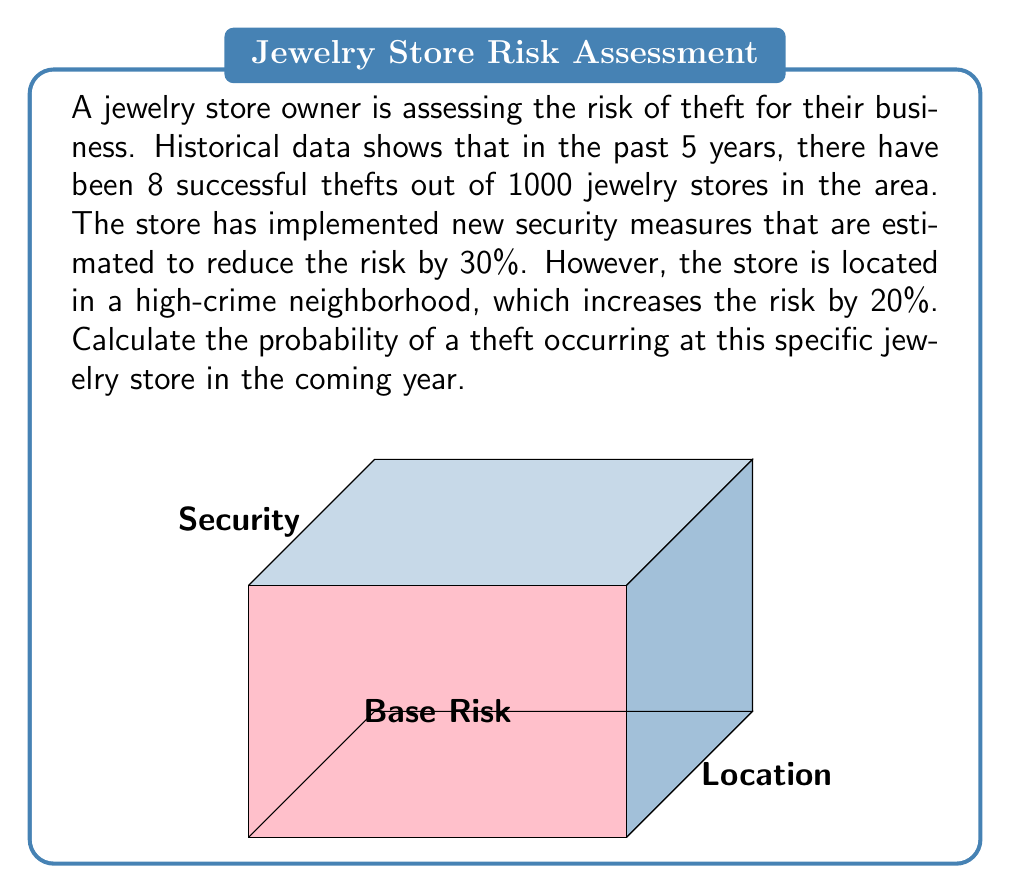Can you answer this question? Let's approach this problem step-by-step:

1) First, calculate the base probability of theft:
   $$P(\text{base}) = \frac{\text{Number of thefts}}{\text{Total stores}} = \frac{8}{1000} = 0.008 \text{ or } 0.8\%$$

2) The new security measures reduce the risk by 30%:
   $$P(\text{security}) = P(\text{base}) \times (1 - 0.30) = 0.008 \times 0.70 = 0.0056$$

3) The high-crime location increases the risk by 20%:
   $$P(\text{location}) = P(\text{security}) \times (1 + 0.20) = 0.0056 \times 1.20 = 0.00672$$

4) Therefore, the final probability is:
   $$P(\text{final}) = 0.00672 \text{ or } 0.672\%$$

To express this as a percentage chance of theft in the coming year:
   $$P(\text{theft}) = 0.00672 \times 100\% = 0.672\%$$
Answer: $0.672\%$ 